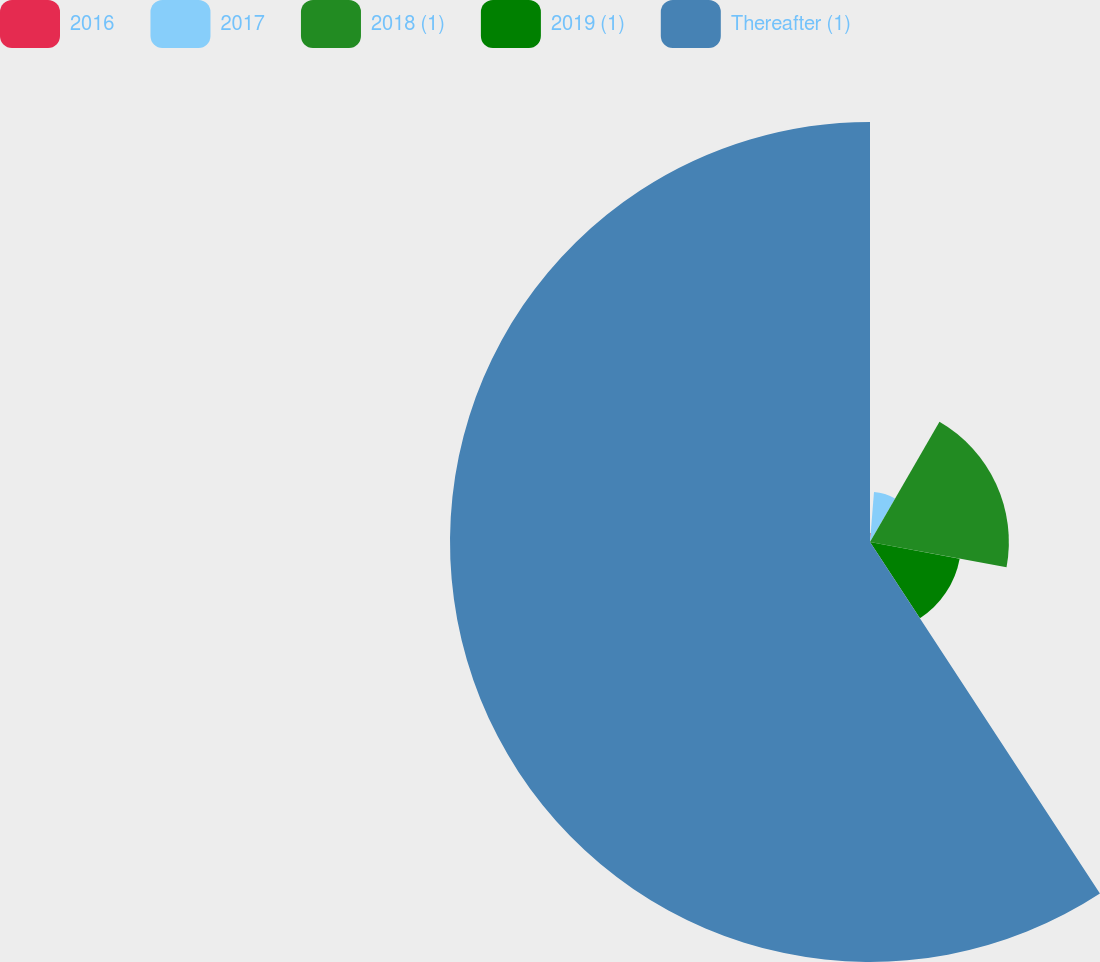Convert chart. <chart><loc_0><loc_0><loc_500><loc_500><pie_chart><fcel>2016<fcel>2017<fcel>2018 (1)<fcel>2019 (1)<fcel>Thereafter (1)<nl><fcel>1.27%<fcel>7.07%<fcel>19.58%<fcel>12.86%<fcel>59.22%<nl></chart> 